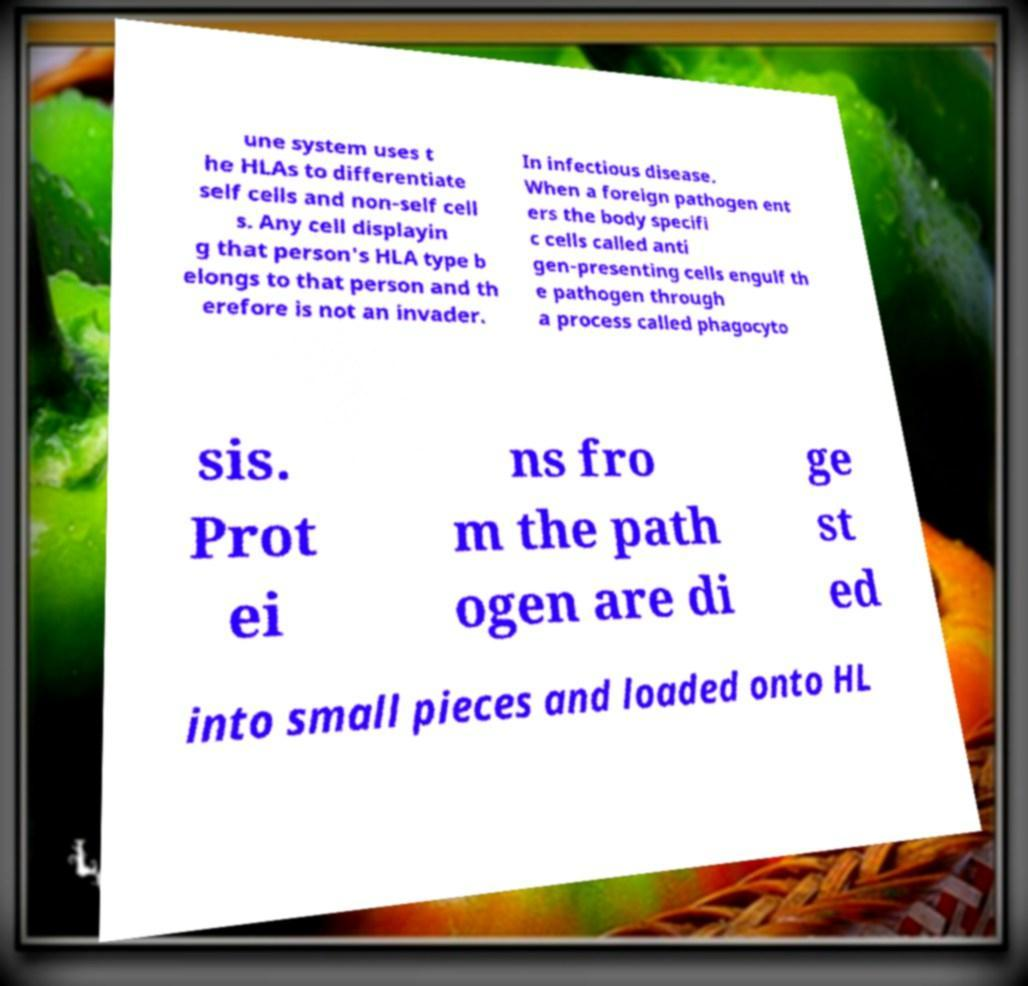Could you extract and type out the text from this image? une system uses t he HLAs to differentiate self cells and non-self cell s. Any cell displayin g that person's HLA type b elongs to that person and th erefore is not an invader. In infectious disease. When a foreign pathogen ent ers the body specifi c cells called anti gen-presenting cells engulf th e pathogen through a process called phagocyto sis. Prot ei ns fro m the path ogen are di ge st ed into small pieces and loaded onto HL 